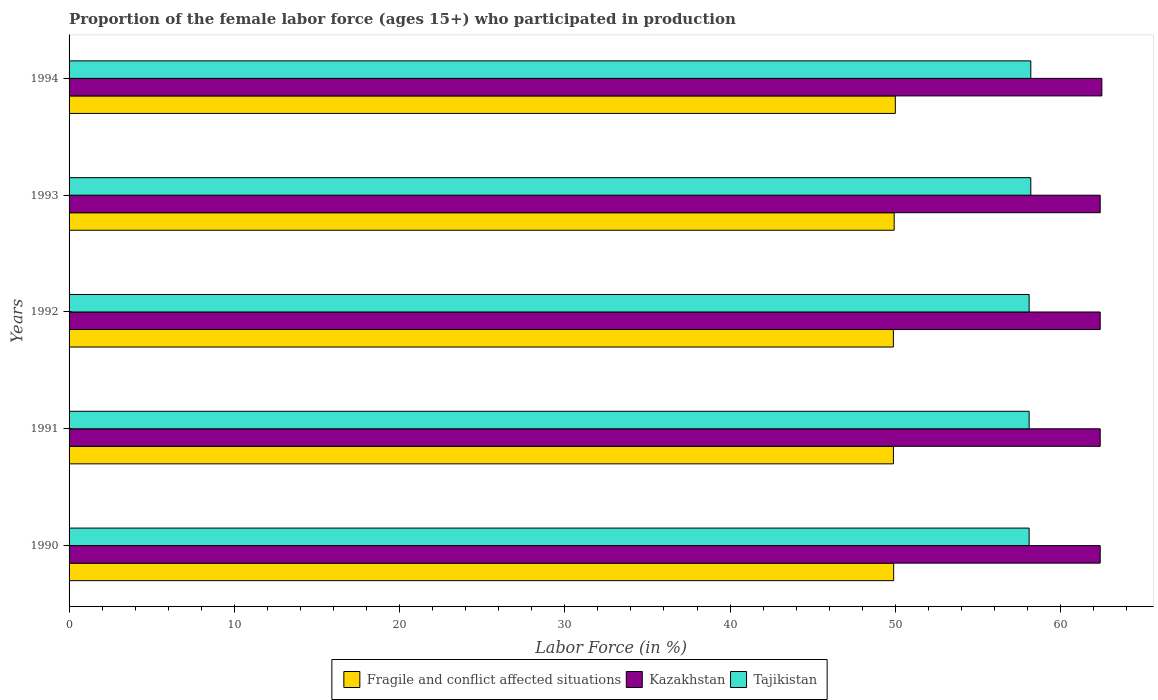How many groups of bars are there?
Give a very brief answer. 5. Are the number of bars per tick equal to the number of legend labels?
Keep it short and to the point. Yes. Are the number of bars on each tick of the Y-axis equal?
Your answer should be very brief. Yes. How many bars are there on the 5th tick from the bottom?
Your response must be concise. 3. What is the label of the 3rd group of bars from the top?
Give a very brief answer. 1992. What is the proportion of the female labor force who participated in production in Tajikistan in 1991?
Ensure brevity in your answer.  58.1. Across all years, what is the maximum proportion of the female labor force who participated in production in Tajikistan?
Give a very brief answer. 58.2. Across all years, what is the minimum proportion of the female labor force who participated in production in Fragile and conflict affected situations?
Provide a succinct answer. 49.88. What is the total proportion of the female labor force who participated in production in Tajikistan in the graph?
Your response must be concise. 290.7. What is the difference between the proportion of the female labor force who participated in production in Tajikistan in 1992 and that in 1993?
Keep it short and to the point. -0.1. What is the difference between the proportion of the female labor force who participated in production in Fragile and conflict affected situations in 1990 and the proportion of the female labor force who participated in production in Kazakhstan in 1994?
Make the answer very short. -12.6. What is the average proportion of the female labor force who participated in production in Fragile and conflict affected situations per year?
Make the answer very short. 49.92. In the year 1990, what is the difference between the proportion of the female labor force who participated in production in Kazakhstan and proportion of the female labor force who participated in production in Fragile and conflict affected situations?
Provide a short and direct response. 12.5. What is the ratio of the proportion of the female labor force who participated in production in Kazakhstan in 1992 to that in 1994?
Your response must be concise. 1. What is the difference between the highest and the second highest proportion of the female labor force who participated in production in Kazakhstan?
Provide a succinct answer. 0.1. What is the difference between the highest and the lowest proportion of the female labor force who participated in production in Fragile and conflict affected situations?
Your answer should be compact. 0.12. In how many years, is the proportion of the female labor force who participated in production in Tajikistan greater than the average proportion of the female labor force who participated in production in Tajikistan taken over all years?
Make the answer very short. 2. Is the sum of the proportion of the female labor force who participated in production in Tajikistan in 1990 and 1992 greater than the maximum proportion of the female labor force who participated in production in Kazakhstan across all years?
Provide a short and direct response. Yes. What does the 2nd bar from the top in 1994 represents?
Provide a succinct answer. Kazakhstan. What does the 3rd bar from the bottom in 1990 represents?
Your response must be concise. Tajikistan. Is it the case that in every year, the sum of the proportion of the female labor force who participated in production in Kazakhstan and proportion of the female labor force who participated in production in Tajikistan is greater than the proportion of the female labor force who participated in production in Fragile and conflict affected situations?
Provide a short and direct response. Yes. Are all the bars in the graph horizontal?
Provide a succinct answer. Yes. Are the values on the major ticks of X-axis written in scientific E-notation?
Offer a very short reply. No. Does the graph contain grids?
Offer a terse response. No. How are the legend labels stacked?
Offer a terse response. Horizontal. What is the title of the graph?
Provide a succinct answer. Proportion of the female labor force (ages 15+) who participated in production. Does "Channel Islands" appear as one of the legend labels in the graph?
Provide a succinct answer. No. What is the label or title of the X-axis?
Your answer should be very brief. Labor Force (in %). What is the label or title of the Y-axis?
Keep it short and to the point. Years. What is the Labor Force (in %) in Fragile and conflict affected situations in 1990?
Provide a succinct answer. 49.9. What is the Labor Force (in %) in Kazakhstan in 1990?
Ensure brevity in your answer.  62.4. What is the Labor Force (in %) of Tajikistan in 1990?
Your answer should be very brief. 58.1. What is the Labor Force (in %) in Fragile and conflict affected situations in 1991?
Give a very brief answer. 49.89. What is the Labor Force (in %) of Kazakhstan in 1991?
Give a very brief answer. 62.4. What is the Labor Force (in %) in Tajikistan in 1991?
Keep it short and to the point. 58.1. What is the Labor Force (in %) in Fragile and conflict affected situations in 1992?
Keep it short and to the point. 49.88. What is the Labor Force (in %) in Kazakhstan in 1992?
Your answer should be compact. 62.4. What is the Labor Force (in %) in Tajikistan in 1992?
Your response must be concise. 58.1. What is the Labor Force (in %) in Fragile and conflict affected situations in 1993?
Keep it short and to the point. 49.93. What is the Labor Force (in %) of Kazakhstan in 1993?
Offer a terse response. 62.4. What is the Labor Force (in %) of Tajikistan in 1993?
Provide a short and direct response. 58.2. What is the Labor Force (in %) in Fragile and conflict affected situations in 1994?
Keep it short and to the point. 50. What is the Labor Force (in %) in Kazakhstan in 1994?
Your answer should be very brief. 62.5. What is the Labor Force (in %) of Tajikistan in 1994?
Offer a terse response. 58.2. Across all years, what is the maximum Labor Force (in %) of Fragile and conflict affected situations?
Your answer should be compact. 50. Across all years, what is the maximum Labor Force (in %) in Kazakhstan?
Make the answer very short. 62.5. Across all years, what is the maximum Labor Force (in %) of Tajikistan?
Your response must be concise. 58.2. Across all years, what is the minimum Labor Force (in %) of Fragile and conflict affected situations?
Your answer should be very brief. 49.88. Across all years, what is the minimum Labor Force (in %) in Kazakhstan?
Keep it short and to the point. 62.4. Across all years, what is the minimum Labor Force (in %) of Tajikistan?
Your answer should be compact. 58.1. What is the total Labor Force (in %) of Fragile and conflict affected situations in the graph?
Give a very brief answer. 249.61. What is the total Labor Force (in %) of Kazakhstan in the graph?
Offer a very short reply. 312.1. What is the total Labor Force (in %) in Tajikistan in the graph?
Make the answer very short. 290.7. What is the difference between the Labor Force (in %) of Fragile and conflict affected situations in 1990 and that in 1991?
Your answer should be very brief. 0.02. What is the difference between the Labor Force (in %) in Tajikistan in 1990 and that in 1991?
Provide a short and direct response. 0. What is the difference between the Labor Force (in %) of Fragile and conflict affected situations in 1990 and that in 1992?
Give a very brief answer. 0.02. What is the difference between the Labor Force (in %) in Fragile and conflict affected situations in 1990 and that in 1993?
Offer a very short reply. -0.03. What is the difference between the Labor Force (in %) of Kazakhstan in 1990 and that in 1993?
Ensure brevity in your answer.  0. What is the difference between the Labor Force (in %) of Tajikistan in 1990 and that in 1993?
Your answer should be very brief. -0.1. What is the difference between the Labor Force (in %) in Fragile and conflict affected situations in 1990 and that in 1994?
Ensure brevity in your answer.  -0.1. What is the difference between the Labor Force (in %) of Fragile and conflict affected situations in 1991 and that in 1992?
Offer a terse response. 0. What is the difference between the Labor Force (in %) in Fragile and conflict affected situations in 1991 and that in 1993?
Offer a terse response. -0.05. What is the difference between the Labor Force (in %) of Kazakhstan in 1991 and that in 1993?
Your answer should be very brief. 0. What is the difference between the Labor Force (in %) of Fragile and conflict affected situations in 1991 and that in 1994?
Offer a very short reply. -0.12. What is the difference between the Labor Force (in %) in Fragile and conflict affected situations in 1992 and that in 1993?
Offer a terse response. -0.05. What is the difference between the Labor Force (in %) in Kazakhstan in 1992 and that in 1993?
Keep it short and to the point. 0. What is the difference between the Labor Force (in %) of Fragile and conflict affected situations in 1992 and that in 1994?
Your answer should be very brief. -0.12. What is the difference between the Labor Force (in %) of Kazakhstan in 1992 and that in 1994?
Keep it short and to the point. -0.1. What is the difference between the Labor Force (in %) of Fragile and conflict affected situations in 1993 and that in 1994?
Keep it short and to the point. -0.07. What is the difference between the Labor Force (in %) of Tajikistan in 1993 and that in 1994?
Provide a short and direct response. 0. What is the difference between the Labor Force (in %) in Fragile and conflict affected situations in 1990 and the Labor Force (in %) in Kazakhstan in 1991?
Ensure brevity in your answer.  -12.5. What is the difference between the Labor Force (in %) of Fragile and conflict affected situations in 1990 and the Labor Force (in %) of Tajikistan in 1991?
Provide a succinct answer. -8.2. What is the difference between the Labor Force (in %) in Fragile and conflict affected situations in 1990 and the Labor Force (in %) in Kazakhstan in 1992?
Provide a succinct answer. -12.5. What is the difference between the Labor Force (in %) in Fragile and conflict affected situations in 1990 and the Labor Force (in %) in Tajikistan in 1992?
Provide a short and direct response. -8.2. What is the difference between the Labor Force (in %) of Fragile and conflict affected situations in 1990 and the Labor Force (in %) of Kazakhstan in 1993?
Your response must be concise. -12.5. What is the difference between the Labor Force (in %) of Fragile and conflict affected situations in 1990 and the Labor Force (in %) of Tajikistan in 1993?
Your response must be concise. -8.3. What is the difference between the Labor Force (in %) in Kazakhstan in 1990 and the Labor Force (in %) in Tajikistan in 1993?
Your response must be concise. 4.2. What is the difference between the Labor Force (in %) in Fragile and conflict affected situations in 1990 and the Labor Force (in %) in Kazakhstan in 1994?
Offer a terse response. -12.6. What is the difference between the Labor Force (in %) of Fragile and conflict affected situations in 1990 and the Labor Force (in %) of Tajikistan in 1994?
Provide a short and direct response. -8.3. What is the difference between the Labor Force (in %) in Fragile and conflict affected situations in 1991 and the Labor Force (in %) in Kazakhstan in 1992?
Give a very brief answer. -12.51. What is the difference between the Labor Force (in %) in Fragile and conflict affected situations in 1991 and the Labor Force (in %) in Tajikistan in 1992?
Offer a very short reply. -8.21. What is the difference between the Labor Force (in %) of Kazakhstan in 1991 and the Labor Force (in %) of Tajikistan in 1992?
Keep it short and to the point. 4.3. What is the difference between the Labor Force (in %) of Fragile and conflict affected situations in 1991 and the Labor Force (in %) of Kazakhstan in 1993?
Your answer should be very brief. -12.51. What is the difference between the Labor Force (in %) in Fragile and conflict affected situations in 1991 and the Labor Force (in %) in Tajikistan in 1993?
Your response must be concise. -8.31. What is the difference between the Labor Force (in %) of Fragile and conflict affected situations in 1991 and the Labor Force (in %) of Kazakhstan in 1994?
Your response must be concise. -12.61. What is the difference between the Labor Force (in %) in Fragile and conflict affected situations in 1991 and the Labor Force (in %) in Tajikistan in 1994?
Give a very brief answer. -8.31. What is the difference between the Labor Force (in %) of Fragile and conflict affected situations in 1992 and the Labor Force (in %) of Kazakhstan in 1993?
Ensure brevity in your answer.  -12.52. What is the difference between the Labor Force (in %) in Fragile and conflict affected situations in 1992 and the Labor Force (in %) in Tajikistan in 1993?
Your response must be concise. -8.32. What is the difference between the Labor Force (in %) in Fragile and conflict affected situations in 1992 and the Labor Force (in %) in Kazakhstan in 1994?
Your response must be concise. -12.62. What is the difference between the Labor Force (in %) in Fragile and conflict affected situations in 1992 and the Labor Force (in %) in Tajikistan in 1994?
Provide a short and direct response. -8.32. What is the difference between the Labor Force (in %) of Fragile and conflict affected situations in 1993 and the Labor Force (in %) of Kazakhstan in 1994?
Your answer should be very brief. -12.57. What is the difference between the Labor Force (in %) of Fragile and conflict affected situations in 1993 and the Labor Force (in %) of Tajikistan in 1994?
Ensure brevity in your answer.  -8.27. What is the difference between the Labor Force (in %) in Kazakhstan in 1993 and the Labor Force (in %) in Tajikistan in 1994?
Give a very brief answer. 4.2. What is the average Labor Force (in %) of Fragile and conflict affected situations per year?
Keep it short and to the point. 49.92. What is the average Labor Force (in %) in Kazakhstan per year?
Make the answer very short. 62.42. What is the average Labor Force (in %) of Tajikistan per year?
Provide a succinct answer. 58.14. In the year 1990, what is the difference between the Labor Force (in %) in Fragile and conflict affected situations and Labor Force (in %) in Kazakhstan?
Give a very brief answer. -12.5. In the year 1990, what is the difference between the Labor Force (in %) of Fragile and conflict affected situations and Labor Force (in %) of Tajikistan?
Make the answer very short. -8.2. In the year 1991, what is the difference between the Labor Force (in %) in Fragile and conflict affected situations and Labor Force (in %) in Kazakhstan?
Your answer should be compact. -12.51. In the year 1991, what is the difference between the Labor Force (in %) of Fragile and conflict affected situations and Labor Force (in %) of Tajikistan?
Make the answer very short. -8.21. In the year 1992, what is the difference between the Labor Force (in %) in Fragile and conflict affected situations and Labor Force (in %) in Kazakhstan?
Your answer should be very brief. -12.52. In the year 1992, what is the difference between the Labor Force (in %) in Fragile and conflict affected situations and Labor Force (in %) in Tajikistan?
Make the answer very short. -8.22. In the year 1993, what is the difference between the Labor Force (in %) in Fragile and conflict affected situations and Labor Force (in %) in Kazakhstan?
Provide a short and direct response. -12.47. In the year 1993, what is the difference between the Labor Force (in %) of Fragile and conflict affected situations and Labor Force (in %) of Tajikistan?
Offer a terse response. -8.27. In the year 1994, what is the difference between the Labor Force (in %) in Fragile and conflict affected situations and Labor Force (in %) in Kazakhstan?
Keep it short and to the point. -12.5. In the year 1994, what is the difference between the Labor Force (in %) of Fragile and conflict affected situations and Labor Force (in %) of Tajikistan?
Offer a very short reply. -8.2. What is the ratio of the Labor Force (in %) of Tajikistan in 1990 to that in 1991?
Provide a short and direct response. 1. What is the ratio of the Labor Force (in %) in Kazakhstan in 1990 to that in 1992?
Give a very brief answer. 1. What is the ratio of the Labor Force (in %) of Tajikistan in 1990 to that in 1992?
Offer a terse response. 1. What is the ratio of the Labor Force (in %) of Fragile and conflict affected situations in 1990 to that in 1993?
Your answer should be very brief. 1. What is the ratio of the Labor Force (in %) of Kazakhstan in 1990 to that in 1993?
Ensure brevity in your answer.  1. What is the ratio of the Labor Force (in %) of Tajikistan in 1990 to that in 1993?
Ensure brevity in your answer.  1. What is the ratio of the Labor Force (in %) in Fragile and conflict affected situations in 1990 to that in 1994?
Your answer should be compact. 1. What is the ratio of the Labor Force (in %) in Kazakhstan in 1990 to that in 1994?
Provide a short and direct response. 1. What is the ratio of the Labor Force (in %) of Tajikistan in 1990 to that in 1994?
Ensure brevity in your answer.  1. What is the ratio of the Labor Force (in %) in Tajikistan in 1991 to that in 1992?
Ensure brevity in your answer.  1. What is the ratio of the Labor Force (in %) of Kazakhstan in 1991 to that in 1994?
Offer a terse response. 1. What is the ratio of the Labor Force (in %) of Fragile and conflict affected situations in 1992 to that in 1993?
Offer a very short reply. 1. What is the ratio of the Labor Force (in %) of Kazakhstan in 1992 to that in 1993?
Offer a terse response. 1. What is the ratio of the Labor Force (in %) in Tajikistan in 1992 to that in 1993?
Give a very brief answer. 1. What is the ratio of the Labor Force (in %) in Fragile and conflict affected situations in 1992 to that in 1994?
Offer a very short reply. 1. What is the ratio of the Labor Force (in %) of Kazakhstan in 1992 to that in 1994?
Offer a terse response. 1. What is the ratio of the Labor Force (in %) of Tajikistan in 1992 to that in 1994?
Offer a very short reply. 1. What is the ratio of the Labor Force (in %) in Tajikistan in 1993 to that in 1994?
Ensure brevity in your answer.  1. What is the difference between the highest and the second highest Labor Force (in %) in Fragile and conflict affected situations?
Your answer should be very brief. 0.07. What is the difference between the highest and the second highest Labor Force (in %) of Kazakhstan?
Keep it short and to the point. 0.1. What is the difference between the highest and the lowest Labor Force (in %) in Fragile and conflict affected situations?
Your answer should be very brief. 0.12. What is the difference between the highest and the lowest Labor Force (in %) of Kazakhstan?
Keep it short and to the point. 0.1. 